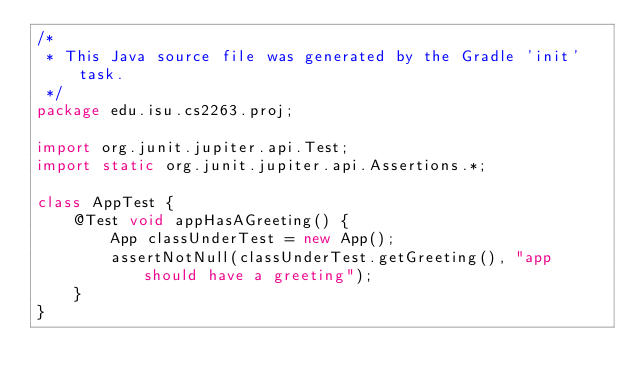<code> <loc_0><loc_0><loc_500><loc_500><_Java_>/*
 * This Java source file was generated by the Gradle 'init' task.
 */
package edu.isu.cs2263.proj;

import org.junit.jupiter.api.Test;
import static org.junit.jupiter.api.Assertions.*;

class AppTest {
    @Test void appHasAGreeting() {
        App classUnderTest = new App();
        assertNotNull(classUnderTest.getGreeting(), "app should have a greeting");
    }
}
</code> 